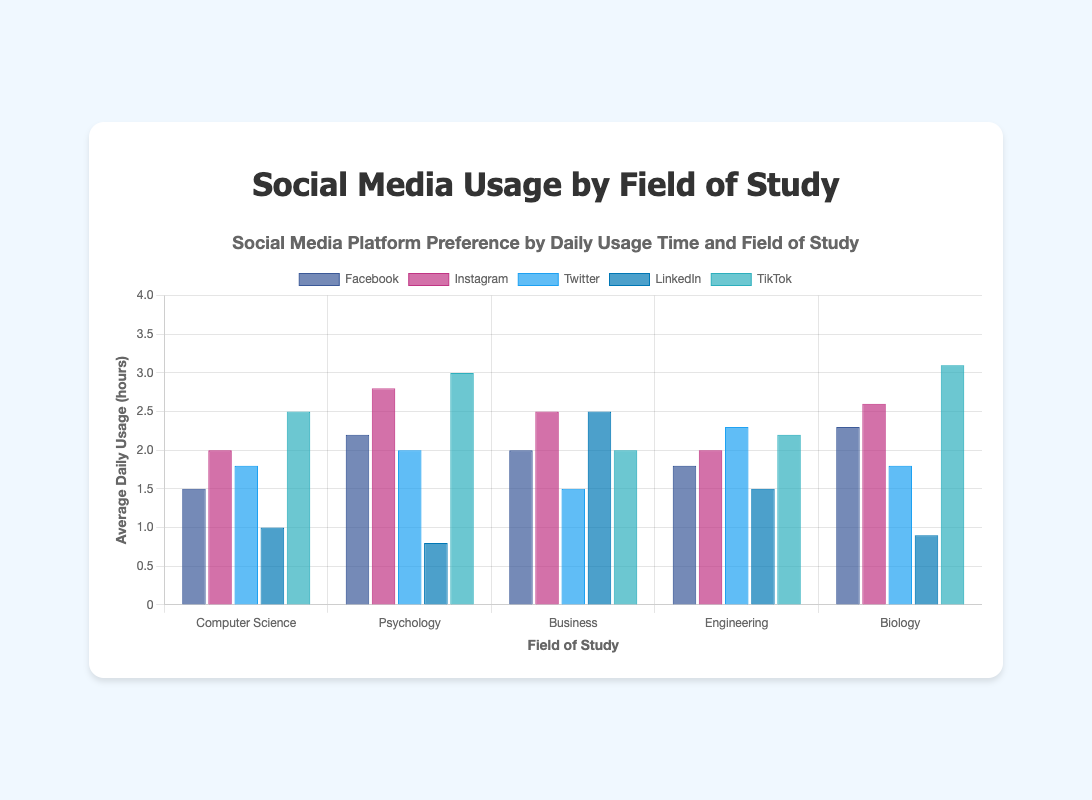What is the total average daily usage of Instagram for all fields of study? To find the total average daily usage of Instagram for all fields of study, we sum the average daily usage hours for each field of study: 2.0 (Computer Science) + 2.8 (Psychology) + 2.5 (Business) + 2.0 (Engineering) + 2.6 (Biology). Therefore, the total is 2.0 + 2.8 + 2.5 + 2.0 + 2.6 = 11.9 hours.
Answer: 11.9 hours Which field of study has the highest average daily usage of LinkedIn? To determine the field of study with the highest average daily usage of LinkedIn, we compare the average daily usage for each field: 1.0 (Computer Science), 0.8 (Psychology), 2.5 (Business), 1.5 (Engineering), 0.9 (Biology). Business has the highest value at 2.5 hours.
Answer: Business How much more does Biology students use TikTok on average daily compared to Computer Science students? To find out the difference in TikTok usage between Biology and Computer Science students, subtract the average daily usage of Computer Science students from that of Biology students: 3.1 (Biology) - 2.5 (Computer Science) = 0.6 hours.
Answer: 0.6 hours Which social media platform has the lowest average daily usage for Psychology students? To find the platform with the lowest usage for Psychology students, we compare the average daily usage hours: Facebook (2.2), Instagram (2.8), Twitter (2.0), LinkedIn (0.8), TikTok (3.0). LinkedIn has the lowest value at 0.8 hours.
Answer: LinkedIn What is the average daily usage of Twitter across all fields of study? To find the average daily usage of Twitter across all fields of study, we calculate the mean of the usage hours: (1.8 + 2.0 + 1.5 + 2.3 + 1.8) / 5. Summing these values, we get 9.4, and dividing by 5, we get 9.4 / 5 = 1.88 hours.
Answer: 1.88 hours What is the difference between the highest and lowest average daily usage of Facebook across the fields of study? To find the difference, we identify the highest and lowest average daily usage values of Facebook: highest is Biology at 2.3 hours and lowest is Computer Science at 1.5 hours. Then, 2.3 - 1.5 = 0.8 hours.
Answer: 0.8 hours Compare the average daily usage of Instagram by Business and Engineering students. Which is higher and by how much? Comparing Instagram usage, Business students use Instagram for 2.5 hours, and Engineering students for 2.0 hours. The difference is 2.5 - 2.0 = 0.5 hours. Business students use it more.
Answer: Business, by 0.5 hours Which field of study uses social media the least on average daily when considering all platforms together? To determine the field with the least usage, we sum the average daily usage hours for each platform in each field and compare the totals: Computer Science (8.8), Psychology (10.8), Business (10.5), Engineering (9.8), Biology (10.7). Computer Science has the lowest total at 8.8 hours.
Answer: Computer Science 